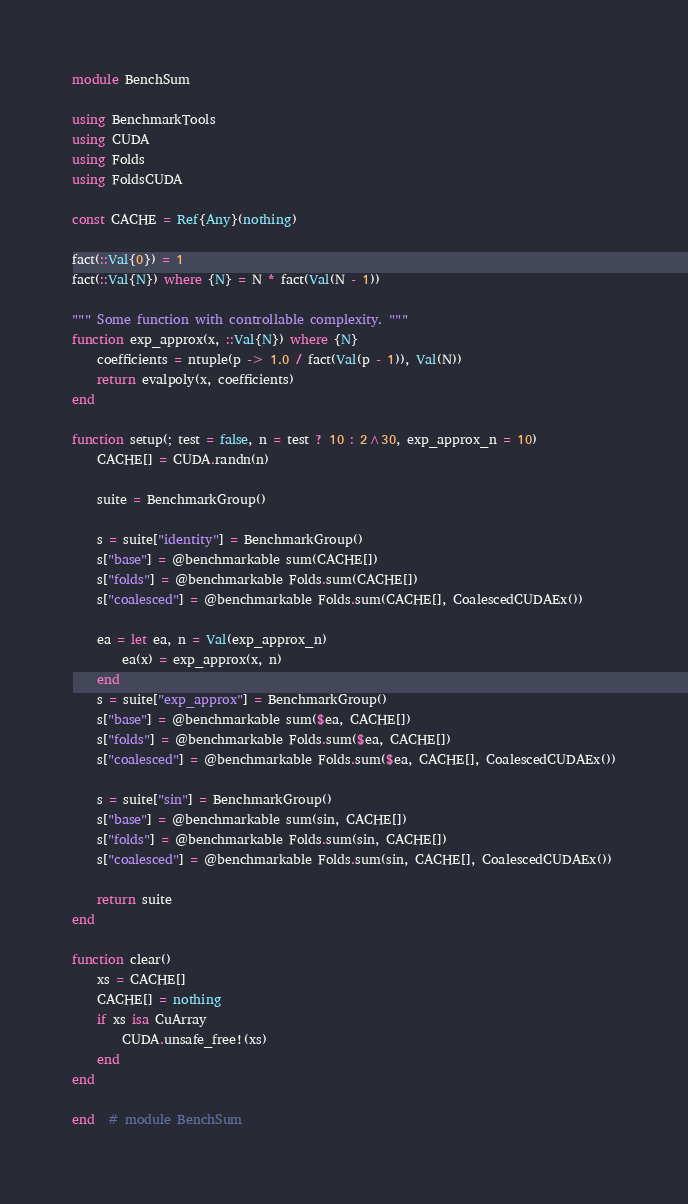Convert code to text. <code><loc_0><loc_0><loc_500><loc_500><_Julia_>module BenchSum

using BenchmarkTools
using CUDA
using Folds
using FoldsCUDA

const CACHE = Ref{Any}(nothing)

fact(::Val{0}) = 1
fact(::Val{N}) where {N} = N * fact(Val(N - 1))

""" Some function with controllable complexity. """
function exp_approx(x, ::Val{N}) where {N}
    coefficients = ntuple(p -> 1.0 / fact(Val(p - 1)), Val(N))
    return evalpoly(x, coefficients)
end

function setup(; test = false, n = test ? 10 : 2^30, exp_approx_n = 10)
    CACHE[] = CUDA.randn(n)

    suite = BenchmarkGroup()

    s = suite["identity"] = BenchmarkGroup()
    s["base"] = @benchmarkable sum(CACHE[])
    s["folds"] = @benchmarkable Folds.sum(CACHE[])
    s["coalesced"] = @benchmarkable Folds.sum(CACHE[], CoalescedCUDAEx())

    ea = let ea, n = Val(exp_approx_n)
        ea(x) = exp_approx(x, n)
    end
    s = suite["exp_approx"] = BenchmarkGroup()
    s["base"] = @benchmarkable sum($ea, CACHE[])
    s["folds"] = @benchmarkable Folds.sum($ea, CACHE[])
    s["coalesced"] = @benchmarkable Folds.sum($ea, CACHE[], CoalescedCUDAEx())

    s = suite["sin"] = BenchmarkGroup()
    s["base"] = @benchmarkable sum(sin, CACHE[])
    s["folds"] = @benchmarkable Folds.sum(sin, CACHE[])
    s["coalesced"] = @benchmarkable Folds.sum(sin, CACHE[], CoalescedCUDAEx())

    return suite
end

function clear()
    xs = CACHE[]
    CACHE[] = nothing
    if xs isa CuArray
        CUDA.unsafe_free!(xs)
    end
end

end  # module BenchSum
</code> 